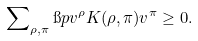<formula> <loc_0><loc_0><loc_500><loc_500>\sum \nolimits _ { \rho , \pi } \i p { v ^ { \rho } } { K ( \rho , \pi ) v ^ { \pi } } \geq 0 .</formula> 